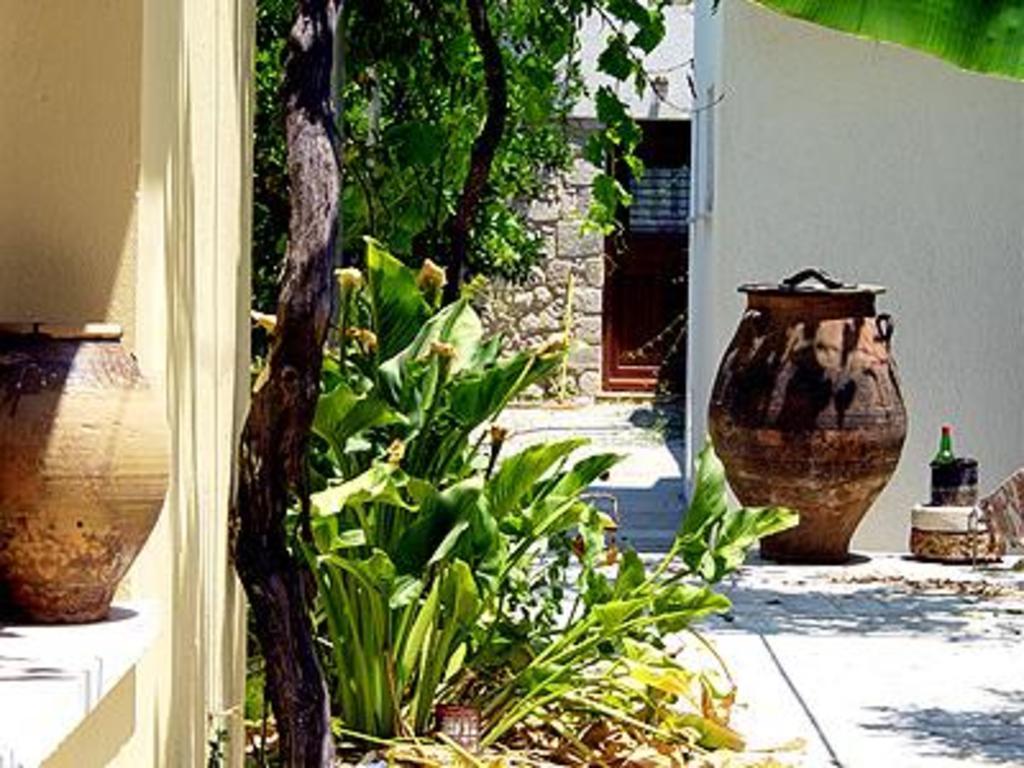Describe this image in one or two sentences. In this image we can see the vases. We can also see some plants, the walls and a bottle in a stand placed on the floor. At the top right we can see a leaf. 